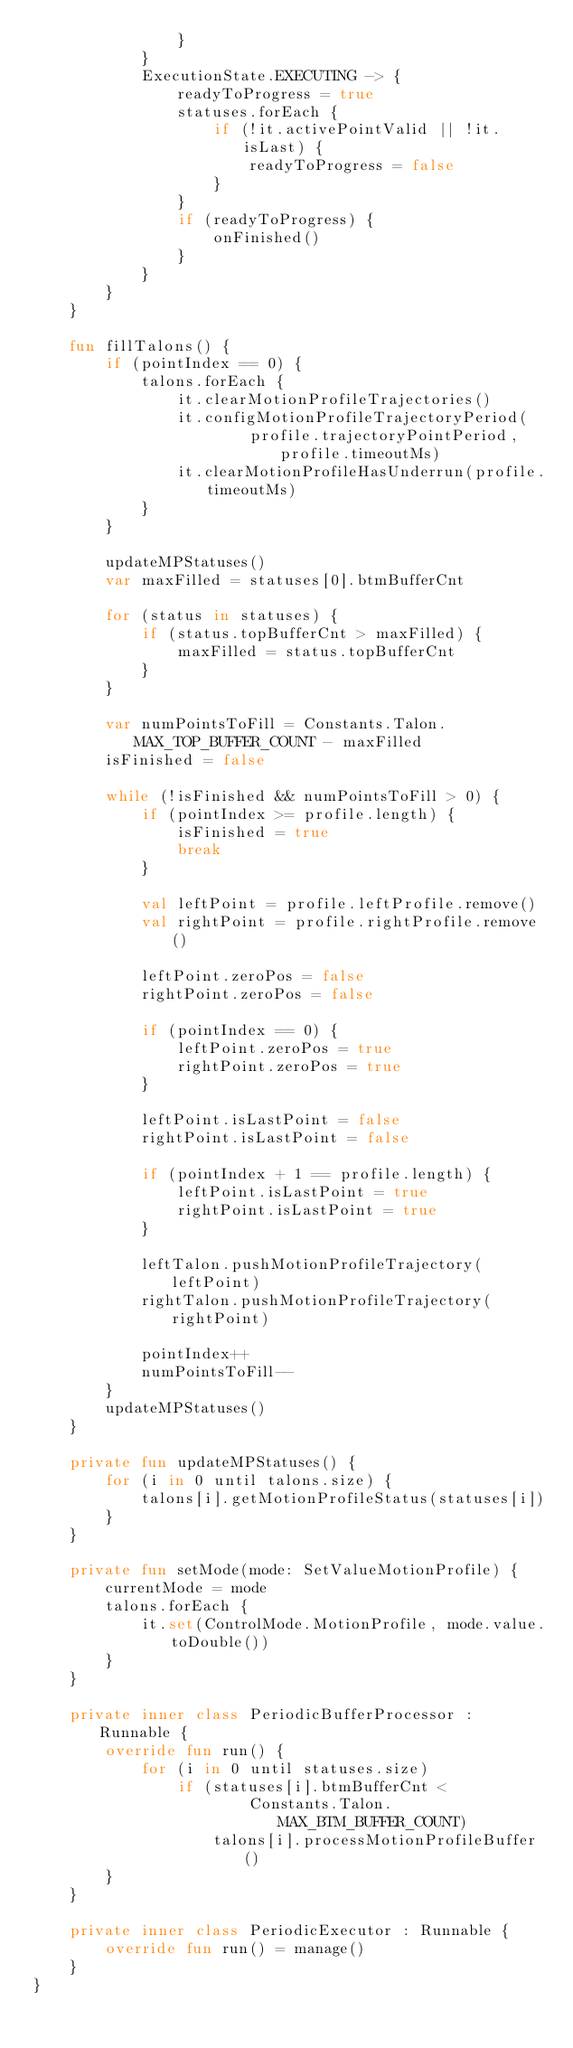<code> <loc_0><loc_0><loc_500><loc_500><_Kotlin_>                }
            }
            ExecutionState.EXECUTING -> {
                readyToProgress = true
                statuses.forEach {
                    if (!it.activePointValid || !it.isLast) {
                        readyToProgress = false
                    }
                }
                if (readyToProgress) {
                    onFinished()
                }
            }
        }
    }

    fun fillTalons() {
        if (pointIndex == 0) {
            talons.forEach {
                it.clearMotionProfileTrajectories()
                it.configMotionProfileTrajectoryPeriod(
                        profile.trajectoryPointPeriod, profile.timeoutMs)
                it.clearMotionProfileHasUnderrun(profile.timeoutMs)
            }
        }

        updateMPStatuses()
        var maxFilled = statuses[0].btmBufferCnt

        for (status in statuses) {
            if (status.topBufferCnt > maxFilled) {
                maxFilled = status.topBufferCnt
            }
        }

        var numPointsToFill = Constants.Talon.MAX_TOP_BUFFER_COUNT - maxFilled
        isFinished = false

        while (!isFinished && numPointsToFill > 0) {
            if (pointIndex >= profile.length) {
                isFinished = true
                break
            }

            val leftPoint = profile.leftProfile.remove()
            val rightPoint = profile.rightProfile.remove()

            leftPoint.zeroPos = false
            rightPoint.zeroPos = false

            if (pointIndex == 0) {
                leftPoint.zeroPos = true
                rightPoint.zeroPos = true
            }

            leftPoint.isLastPoint = false
            rightPoint.isLastPoint = false

            if (pointIndex + 1 == profile.length) {
                leftPoint.isLastPoint = true
                rightPoint.isLastPoint = true
            }

            leftTalon.pushMotionProfileTrajectory(leftPoint)
            rightTalon.pushMotionProfileTrajectory(rightPoint)

            pointIndex++
            numPointsToFill--
        }
        updateMPStatuses()
    }

    private fun updateMPStatuses() {
        for (i in 0 until talons.size) {
            talons[i].getMotionProfileStatus(statuses[i])
        }
    }

    private fun setMode(mode: SetValueMotionProfile) {
        currentMode = mode
        talons.forEach {
            it.set(ControlMode.MotionProfile, mode.value.toDouble())
        }
    }

    private inner class PeriodicBufferProcessor : Runnable {
        override fun run() {
            for (i in 0 until statuses.size)
                if (statuses[i].btmBufferCnt <
                        Constants.Talon.MAX_BTM_BUFFER_COUNT)
                    talons[i].processMotionProfileBuffer()
        }
    }

    private inner class PeriodicExecutor : Runnable {
        override fun run() = manage()
    }
}</code> 